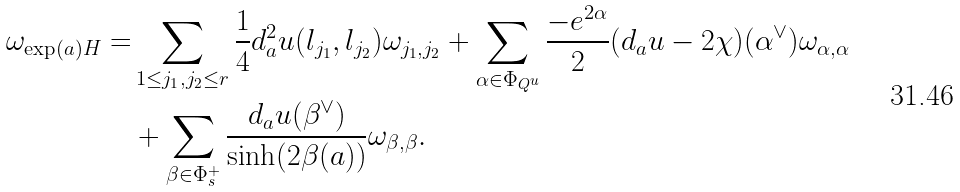<formula> <loc_0><loc_0><loc_500><loc_500>\omega _ { \exp ( a ) H } = & \sum _ { 1 \leq j _ { 1 } , j _ { 2 } \leq r } \frac { 1 } { 4 } d ^ { 2 } _ { a } u ( l _ { j _ { 1 } } , l _ { j _ { 2 } } ) \omega _ { j _ { 1 } , j _ { 2 } } + \sum _ { \alpha \in \Phi _ { Q ^ { u } } } \frac { - e ^ { 2 \alpha } } { 2 } ( d _ { a } u - 2 \chi ) ( \alpha ^ { \vee } ) \omega _ { \alpha , \alpha } \\ & + \sum _ { \beta \in \Phi _ { s } ^ { + } } \frac { d _ { a } u ( \beta ^ { \vee } ) } { \sinh ( 2 \beta ( a ) ) } \omega _ { \beta , \beta } .</formula> 